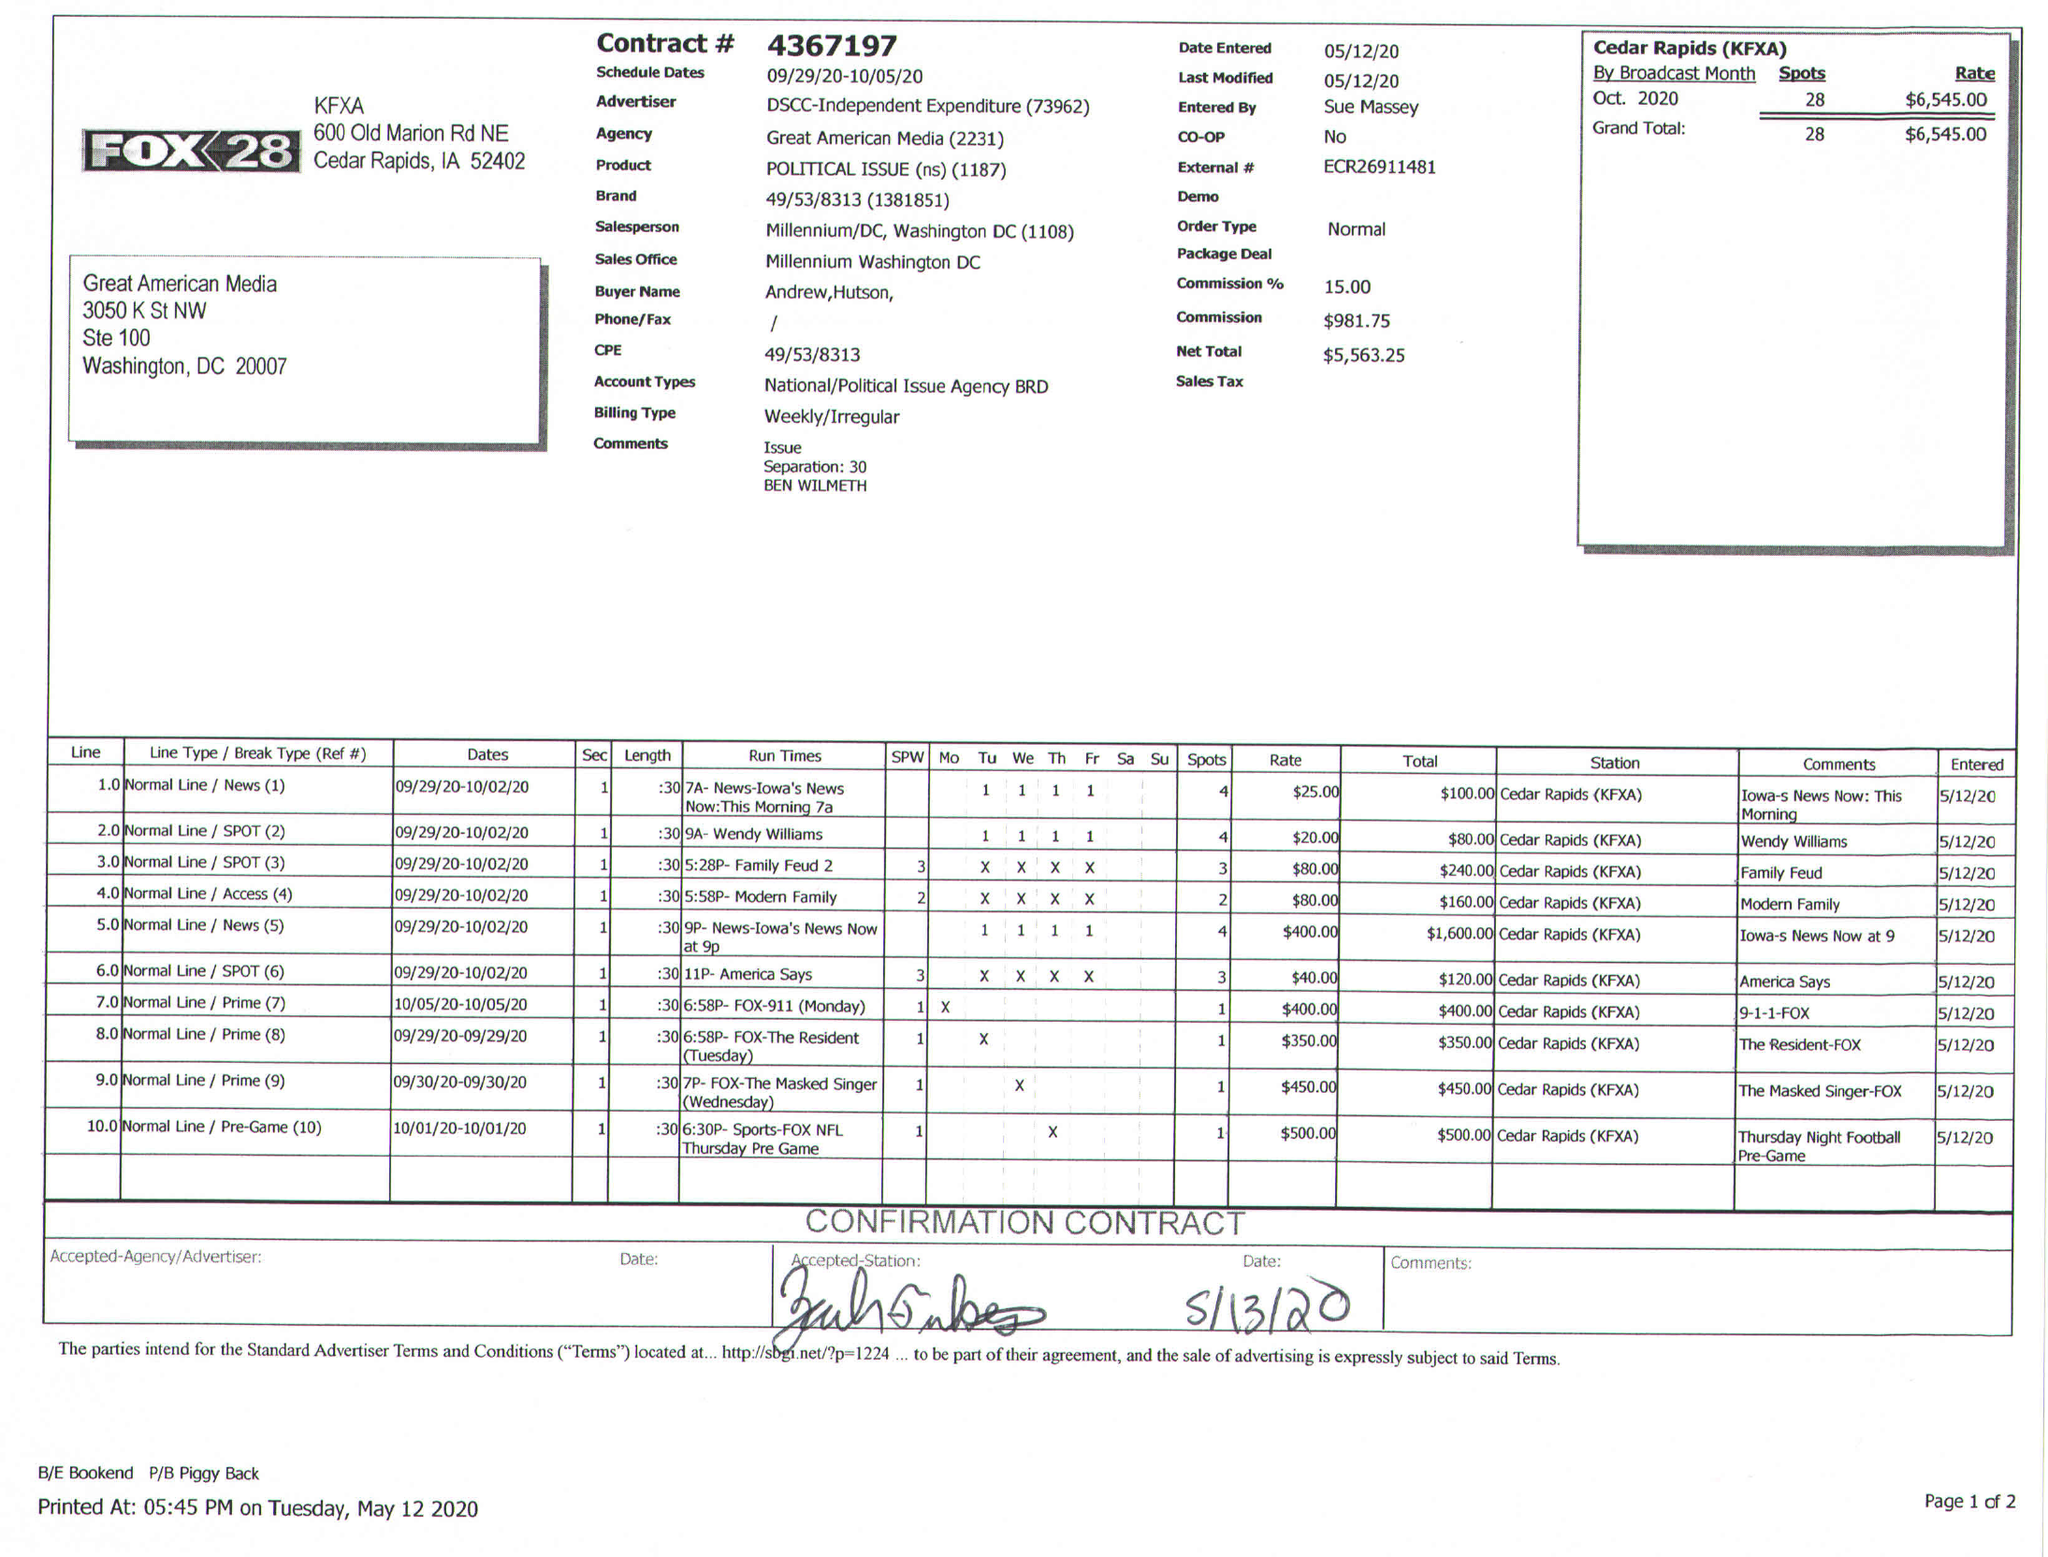What is the value for the advertiser?
Answer the question using a single word or phrase. DSCC 